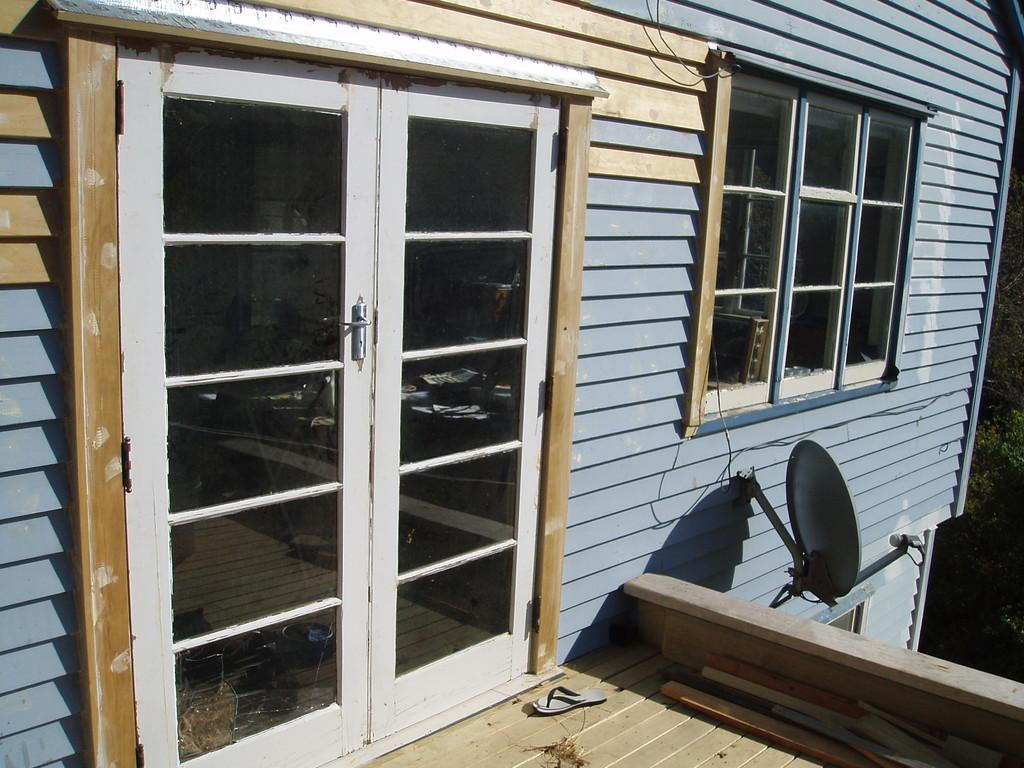What type of structure is in the image? There is a building in the image. What can be seen on the right side of the image? There is a tree on the right side of the image. What are the entry points to the building? There are doors visible in the image. What is the purpose of the object on the building? There is an antenna on the building, which is likely used for communication or broadcasting. What item is present near the building? A slipper is present in the image. What type of soup is being served in the image? There is no soup present in the image; it features a building, a tree, doors, an antenna, and a slipper. 